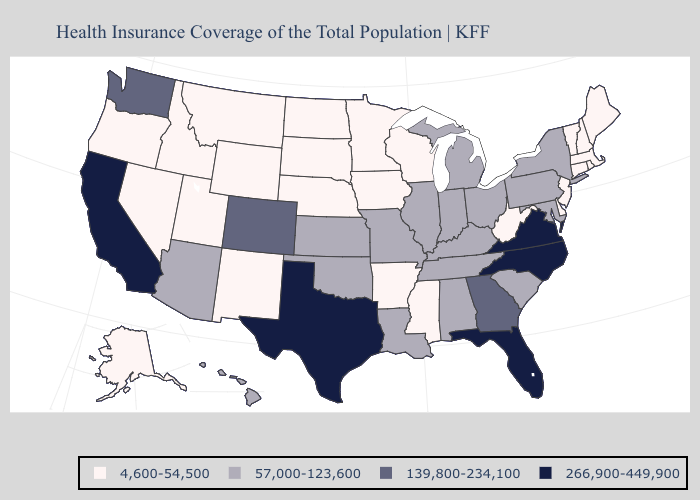What is the lowest value in the South?
Answer briefly. 4,600-54,500. Name the states that have a value in the range 266,900-449,900?
Quick response, please. California, Florida, North Carolina, Texas, Virginia. Does South Dakota have the highest value in the MidWest?
Short answer required. No. What is the value of Hawaii?
Write a very short answer. 57,000-123,600. Does North Carolina have the highest value in the USA?
Keep it brief. Yes. What is the value of Alaska?
Short answer required. 4,600-54,500. What is the value of Maryland?
Write a very short answer. 57,000-123,600. Name the states that have a value in the range 266,900-449,900?
Short answer required. California, Florida, North Carolina, Texas, Virginia. Does Virginia have the highest value in the South?
Keep it brief. Yes. Does Pennsylvania have a higher value than Alaska?
Quick response, please. Yes. Which states have the highest value in the USA?
Answer briefly. California, Florida, North Carolina, Texas, Virginia. Name the states that have a value in the range 266,900-449,900?
Keep it brief. California, Florida, North Carolina, Texas, Virginia. Does Tennessee have the same value as California?
Write a very short answer. No. 